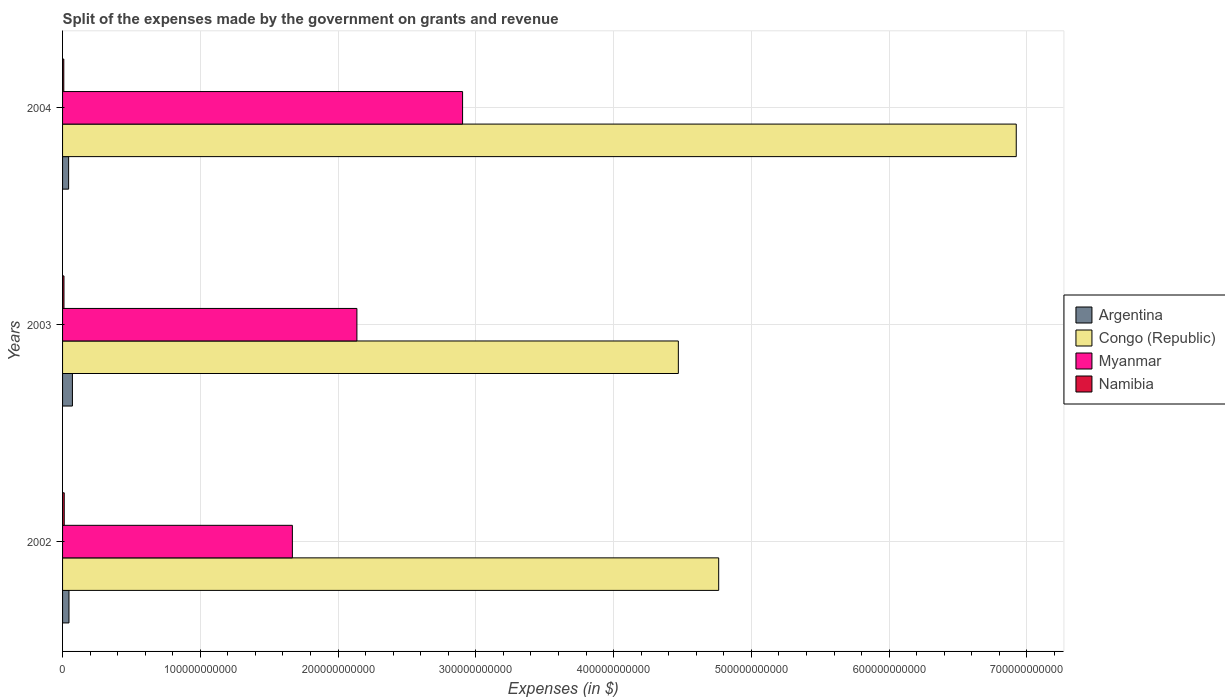How many different coloured bars are there?
Make the answer very short. 4. How many groups of bars are there?
Your response must be concise. 3. Are the number of bars on each tick of the Y-axis equal?
Make the answer very short. Yes. How many bars are there on the 1st tick from the top?
Give a very brief answer. 4. What is the expenses made by the government on grants and revenue in Congo (Republic) in 2003?
Make the answer very short. 4.47e+11. Across all years, what is the maximum expenses made by the government on grants and revenue in Myanmar?
Your answer should be compact. 2.90e+11. Across all years, what is the minimum expenses made by the government on grants and revenue in Argentina?
Keep it short and to the point. 4.39e+09. In which year was the expenses made by the government on grants and revenue in Congo (Republic) minimum?
Keep it short and to the point. 2003. What is the total expenses made by the government on grants and revenue in Namibia in the graph?
Provide a succinct answer. 3.15e+09. What is the difference between the expenses made by the government on grants and revenue in Congo (Republic) in 2003 and that in 2004?
Give a very brief answer. -2.45e+11. What is the difference between the expenses made by the government on grants and revenue in Argentina in 2003 and the expenses made by the government on grants and revenue in Namibia in 2002?
Make the answer very short. 5.94e+09. What is the average expenses made by the government on grants and revenue in Namibia per year?
Your answer should be compact. 1.05e+09. In the year 2004, what is the difference between the expenses made by the government on grants and revenue in Argentina and expenses made by the government on grants and revenue in Myanmar?
Provide a short and direct response. -2.86e+11. What is the ratio of the expenses made by the government on grants and revenue in Myanmar in 2002 to that in 2003?
Your answer should be very brief. 0.78. Is the expenses made by the government on grants and revenue in Congo (Republic) in 2003 less than that in 2004?
Your answer should be compact. Yes. What is the difference between the highest and the second highest expenses made by the government on grants and revenue in Argentina?
Ensure brevity in your answer.  2.49e+09. What is the difference between the highest and the lowest expenses made by the government on grants and revenue in Namibia?
Provide a succinct answer. 3.16e+08. In how many years, is the expenses made by the government on grants and revenue in Congo (Republic) greater than the average expenses made by the government on grants and revenue in Congo (Republic) taken over all years?
Provide a succinct answer. 1. Is the sum of the expenses made by the government on grants and revenue in Namibia in 2002 and 2004 greater than the maximum expenses made by the government on grants and revenue in Congo (Republic) across all years?
Offer a terse response. No. What does the 1st bar from the top in 2002 represents?
Ensure brevity in your answer.  Namibia. What does the 1st bar from the bottom in 2003 represents?
Offer a terse response. Argentina. Is it the case that in every year, the sum of the expenses made by the government on grants and revenue in Namibia and expenses made by the government on grants and revenue in Myanmar is greater than the expenses made by the government on grants and revenue in Argentina?
Make the answer very short. Yes. How many bars are there?
Your answer should be compact. 12. What is the difference between two consecutive major ticks on the X-axis?
Your response must be concise. 1.00e+11. Are the values on the major ticks of X-axis written in scientific E-notation?
Your answer should be very brief. No. How many legend labels are there?
Keep it short and to the point. 4. How are the legend labels stacked?
Offer a terse response. Vertical. What is the title of the graph?
Your answer should be very brief. Split of the expenses made by the government on grants and revenue. Does "Brazil" appear as one of the legend labels in the graph?
Your response must be concise. No. What is the label or title of the X-axis?
Provide a succinct answer. Expenses (in $). What is the Expenses (in $) in Argentina in 2002?
Keep it short and to the point. 4.66e+09. What is the Expenses (in $) of Congo (Republic) in 2002?
Give a very brief answer. 4.76e+11. What is the Expenses (in $) of Myanmar in 2002?
Your answer should be compact. 1.67e+11. What is the Expenses (in $) of Namibia in 2002?
Your answer should be compact. 1.21e+09. What is the Expenses (in $) in Argentina in 2003?
Provide a short and direct response. 7.15e+09. What is the Expenses (in $) of Congo (Republic) in 2003?
Keep it short and to the point. 4.47e+11. What is the Expenses (in $) of Myanmar in 2003?
Provide a short and direct response. 2.14e+11. What is the Expenses (in $) of Namibia in 2003?
Give a very brief answer. 1.03e+09. What is the Expenses (in $) in Argentina in 2004?
Provide a succinct answer. 4.39e+09. What is the Expenses (in $) of Congo (Republic) in 2004?
Make the answer very short. 6.92e+11. What is the Expenses (in $) in Myanmar in 2004?
Give a very brief answer. 2.90e+11. What is the Expenses (in $) in Namibia in 2004?
Provide a succinct answer. 8.97e+08. Across all years, what is the maximum Expenses (in $) in Argentina?
Keep it short and to the point. 7.15e+09. Across all years, what is the maximum Expenses (in $) in Congo (Republic)?
Your answer should be very brief. 6.92e+11. Across all years, what is the maximum Expenses (in $) in Myanmar?
Your answer should be very brief. 2.90e+11. Across all years, what is the maximum Expenses (in $) of Namibia?
Provide a short and direct response. 1.21e+09. Across all years, what is the minimum Expenses (in $) of Argentina?
Keep it short and to the point. 4.39e+09. Across all years, what is the minimum Expenses (in $) in Congo (Republic)?
Your response must be concise. 4.47e+11. Across all years, what is the minimum Expenses (in $) in Myanmar?
Make the answer very short. 1.67e+11. Across all years, what is the minimum Expenses (in $) in Namibia?
Give a very brief answer. 8.97e+08. What is the total Expenses (in $) of Argentina in the graph?
Give a very brief answer. 1.62e+1. What is the total Expenses (in $) in Congo (Republic) in the graph?
Your response must be concise. 1.62e+12. What is the total Expenses (in $) of Myanmar in the graph?
Your answer should be compact. 6.71e+11. What is the total Expenses (in $) in Namibia in the graph?
Your answer should be compact. 3.15e+09. What is the difference between the Expenses (in $) of Argentina in 2002 and that in 2003?
Offer a terse response. -2.49e+09. What is the difference between the Expenses (in $) of Congo (Republic) in 2002 and that in 2003?
Your answer should be very brief. 2.93e+1. What is the difference between the Expenses (in $) of Myanmar in 2002 and that in 2003?
Keep it short and to the point. -4.68e+1. What is the difference between the Expenses (in $) of Namibia in 2002 and that in 2003?
Offer a terse response. 1.78e+08. What is the difference between the Expenses (in $) of Argentina in 2002 and that in 2004?
Offer a terse response. 2.69e+08. What is the difference between the Expenses (in $) of Congo (Republic) in 2002 and that in 2004?
Keep it short and to the point. -2.16e+11. What is the difference between the Expenses (in $) of Myanmar in 2002 and that in 2004?
Your answer should be very brief. -1.24e+11. What is the difference between the Expenses (in $) in Namibia in 2002 and that in 2004?
Your answer should be compact. 3.16e+08. What is the difference between the Expenses (in $) of Argentina in 2003 and that in 2004?
Offer a terse response. 2.76e+09. What is the difference between the Expenses (in $) of Congo (Republic) in 2003 and that in 2004?
Keep it short and to the point. -2.45e+11. What is the difference between the Expenses (in $) in Myanmar in 2003 and that in 2004?
Make the answer very short. -7.67e+1. What is the difference between the Expenses (in $) in Namibia in 2003 and that in 2004?
Ensure brevity in your answer.  1.38e+08. What is the difference between the Expenses (in $) in Argentina in 2002 and the Expenses (in $) in Congo (Republic) in 2003?
Offer a very short reply. -4.42e+11. What is the difference between the Expenses (in $) of Argentina in 2002 and the Expenses (in $) of Myanmar in 2003?
Your answer should be compact. -2.09e+11. What is the difference between the Expenses (in $) of Argentina in 2002 and the Expenses (in $) of Namibia in 2003?
Your response must be concise. 3.63e+09. What is the difference between the Expenses (in $) in Congo (Republic) in 2002 and the Expenses (in $) in Myanmar in 2003?
Keep it short and to the point. 2.63e+11. What is the difference between the Expenses (in $) in Congo (Republic) in 2002 and the Expenses (in $) in Namibia in 2003?
Your response must be concise. 4.75e+11. What is the difference between the Expenses (in $) of Myanmar in 2002 and the Expenses (in $) of Namibia in 2003?
Provide a succinct answer. 1.66e+11. What is the difference between the Expenses (in $) of Argentina in 2002 and the Expenses (in $) of Congo (Republic) in 2004?
Give a very brief answer. -6.88e+11. What is the difference between the Expenses (in $) of Argentina in 2002 and the Expenses (in $) of Myanmar in 2004?
Your answer should be compact. -2.86e+11. What is the difference between the Expenses (in $) of Argentina in 2002 and the Expenses (in $) of Namibia in 2004?
Keep it short and to the point. 3.76e+09. What is the difference between the Expenses (in $) in Congo (Republic) in 2002 and the Expenses (in $) in Myanmar in 2004?
Offer a terse response. 1.86e+11. What is the difference between the Expenses (in $) in Congo (Republic) in 2002 and the Expenses (in $) in Namibia in 2004?
Make the answer very short. 4.75e+11. What is the difference between the Expenses (in $) of Myanmar in 2002 and the Expenses (in $) of Namibia in 2004?
Ensure brevity in your answer.  1.66e+11. What is the difference between the Expenses (in $) in Argentina in 2003 and the Expenses (in $) in Congo (Republic) in 2004?
Provide a succinct answer. -6.85e+11. What is the difference between the Expenses (in $) of Argentina in 2003 and the Expenses (in $) of Myanmar in 2004?
Offer a terse response. -2.83e+11. What is the difference between the Expenses (in $) of Argentina in 2003 and the Expenses (in $) of Namibia in 2004?
Make the answer very short. 6.25e+09. What is the difference between the Expenses (in $) in Congo (Republic) in 2003 and the Expenses (in $) in Myanmar in 2004?
Give a very brief answer. 1.57e+11. What is the difference between the Expenses (in $) in Congo (Republic) in 2003 and the Expenses (in $) in Namibia in 2004?
Provide a short and direct response. 4.46e+11. What is the difference between the Expenses (in $) in Myanmar in 2003 and the Expenses (in $) in Namibia in 2004?
Your answer should be very brief. 2.13e+11. What is the average Expenses (in $) of Argentina per year?
Offer a terse response. 5.40e+09. What is the average Expenses (in $) of Congo (Republic) per year?
Ensure brevity in your answer.  5.39e+11. What is the average Expenses (in $) in Myanmar per year?
Offer a terse response. 2.24e+11. What is the average Expenses (in $) of Namibia per year?
Offer a terse response. 1.05e+09. In the year 2002, what is the difference between the Expenses (in $) of Argentina and Expenses (in $) of Congo (Republic)?
Keep it short and to the point. -4.72e+11. In the year 2002, what is the difference between the Expenses (in $) in Argentina and Expenses (in $) in Myanmar?
Your answer should be compact. -1.62e+11. In the year 2002, what is the difference between the Expenses (in $) in Argentina and Expenses (in $) in Namibia?
Give a very brief answer. 3.45e+09. In the year 2002, what is the difference between the Expenses (in $) of Congo (Republic) and Expenses (in $) of Myanmar?
Offer a terse response. 3.09e+11. In the year 2002, what is the difference between the Expenses (in $) in Congo (Republic) and Expenses (in $) in Namibia?
Provide a short and direct response. 4.75e+11. In the year 2002, what is the difference between the Expenses (in $) in Myanmar and Expenses (in $) in Namibia?
Your answer should be compact. 1.66e+11. In the year 2003, what is the difference between the Expenses (in $) in Argentina and Expenses (in $) in Congo (Republic)?
Your response must be concise. -4.40e+11. In the year 2003, what is the difference between the Expenses (in $) in Argentina and Expenses (in $) in Myanmar?
Provide a succinct answer. -2.07e+11. In the year 2003, what is the difference between the Expenses (in $) in Argentina and Expenses (in $) in Namibia?
Your answer should be compact. 6.12e+09. In the year 2003, what is the difference between the Expenses (in $) of Congo (Republic) and Expenses (in $) of Myanmar?
Your response must be concise. 2.33e+11. In the year 2003, what is the difference between the Expenses (in $) in Congo (Republic) and Expenses (in $) in Namibia?
Your response must be concise. 4.46e+11. In the year 2003, what is the difference between the Expenses (in $) of Myanmar and Expenses (in $) of Namibia?
Make the answer very short. 2.13e+11. In the year 2004, what is the difference between the Expenses (in $) in Argentina and Expenses (in $) in Congo (Republic)?
Your answer should be compact. -6.88e+11. In the year 2004, what is the difference between the Expenses (in $) in Argentina and Expenses (in $) in Myanmar?
Ensure brevity in your answer.  -2.86e+11. In the year 2004, what is the difference between the Expenses (in $) in Argentina and Expenses (in $) in Namibia?
Give a very brief answer. 3.50e+09. In the year 2004, what is the difference between the Expenses (in $) of Congo (Republic) and Expenses (in $) of Myanmar?
Provide a short and direct response. 4.02e+11. In the year 2004, what is the difference between the Expenses (in $) of Congo (Republic) and Expenses (in $) of Namibia?
Your answer should be very brief. 6.91e+11. In the year 2004, what is the difference between the Expenses (in $) of Myanmar and Expenses (in $) of Namibia?
Provide a succinct answer. 2.89e+11. What is the ratio of the Expenses (in $) of Argentina in 2002 to that in 2003?
Give a very brief answer. 0.65. What is the ratio of the Expenses (in $) in Congo (Republic) in 2002 to that in 2003?
Provide a succinct answer. 1.07. What is the ratio of the Expenses (in $) in Myanmar in 2002 to that in 2003?
Give a very brief answer. 0.78. What is the ratio of the Expenses (in $) of Namibia in 2002 to that in 2003?
Offer a very short reply. 1.17. What is the ratio of the Expenses (in $) of Argentina in 2002 to that in 2004?
Offer a very short reply. 1.06. What is the ratio of the Expenses (in $) in Congo (Republic) in 2002 to that in 2004?
Offer a very short reply. 0.69. What is the ratio of the Expenses (in $) in Myanmar in 2002 to that in 2004?
Your answer should be compact. 0.57. What is the ratio of the Expenses (in $) in Namibia in 2002 to that in 2004?
Your answer should be very brief. 1.35. What is the ratio of the Expenses (in $) of Argentina in 2003 to that in 2004?
Keep it short and to the point. 1.63. What is the ratio of the Expenses (in $) in Congo (Republic) in 2003 to that in 2004?
Provide a succinct answer. 0.65. What is the ratio of the Expenses (in $) of Myanmar in 2003 to that in 2004?
Your answer should be very brief. 0.74. What is the ratio of the Expenses (in $) of Namibia in 2003 to that in 2004?
Provide a short and direct response. 1.15. What is the difference between the highest and the second highest Expenses (in $) in Argentina?
Your response must be concise. 2.49e+09. What is the difference between the highest and the second highest Expenses (in $) in Congo (Republic)?
Offer a terse response. 2.16e+11. What is the difference between the highest and the second highest Expenses (in $) of Myanmar?
Make the answer very short. 7.67e+1. What is the difference between the highest and the second highest Expenses (in $) of Namibia?
Offer a very short reply. 1.78e+08. What is the difference between the highest and the lowest Expenses (in $) of Argentina?
Ensure brevity in your answer.  2.76e+09. What is the difference between the highest and the lowest Expenses (in $) of Congo (Republic)?
Provide a succinct answer. 2.45e+11. What is the difference between the highest and the lowest Expenses (in $) in Myanmar?
Provide a short and direct response. 1.24e+11. What is the difference between the highest and the lowest Expenses (in $) in Namibia?
Keep it short and to the point. 3.16e+08. 